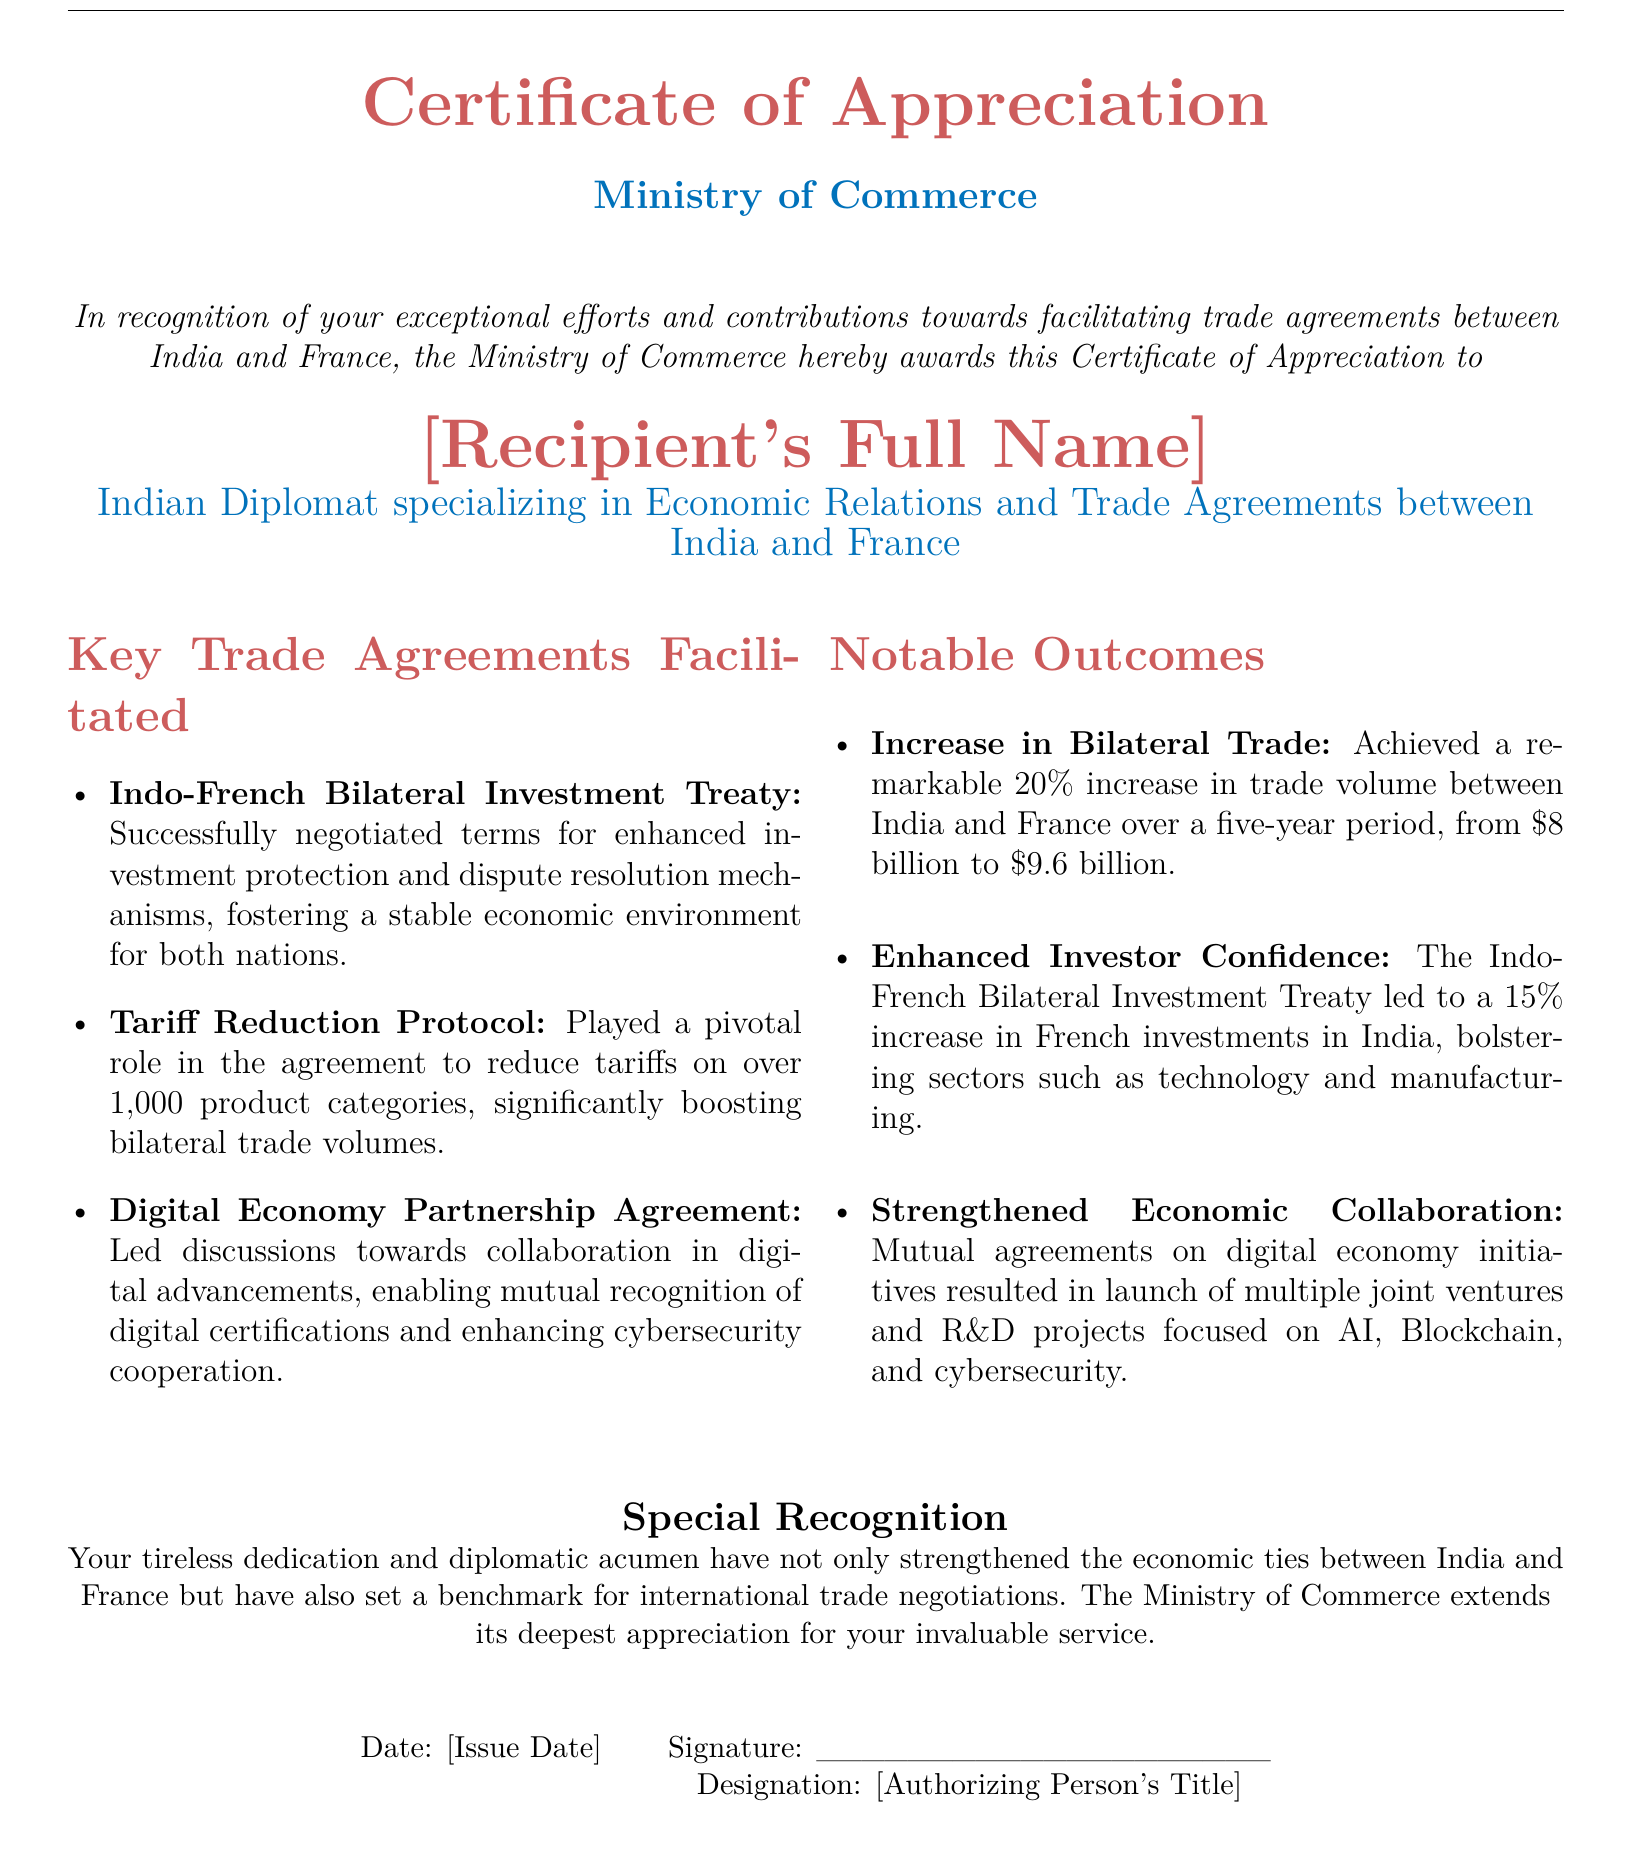What is the title of the document? The title at the top of the document indicates the purpose of the certificate.
Answer: Certificate of Appreciation Who issued the certificate? The issuing authority is mentioned at the beginning of the certificate.
Answer: Ministry of Commerce What is the recipient's profession? The document specifies the recipient's title below their name.
Answer: Indian Diplomat specializing in Economic Relations and Trade Agreements between India and France What is one of the key trade agreements facilitated? The document lists several trade agreements under "Key Trade Agreements Facilitated."
Answer: Indo-French Bilateral Investment Treaty By what percentage did bilateral trade increase? The document states the specific percentage increase in trade volume as noted under "Notable Outcomes."
Answer: 20% What was the increase in French investments in India after the treaty? The document provides a specific percentage increase as a notable outcome of the agreement.
Answer: 15% What was the original trade volume between India and France before the increase? The document specifies the previous trade volume before the reported increase in a notable outcome.
Answer: 8 billion What type of joint ventures were launched due to the agreements? The document highlights the areas of collaboration as part of the outcomes of the agreements.
Answer: AI, Blockchain, and cybersecurity What does the certificate acknowledge about the recipient's contributions? The document includes a statement of recognition for the recipient's efforts.
Answer: Exceptional efforts and contributions 